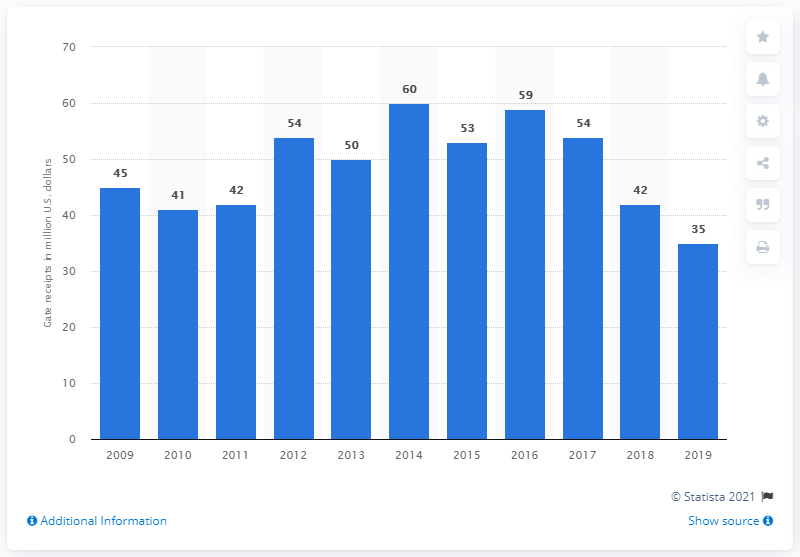Identify some key points in this picture. In 2019, the gate receipts of the Baltimore Orioles were approximately $35 million. 